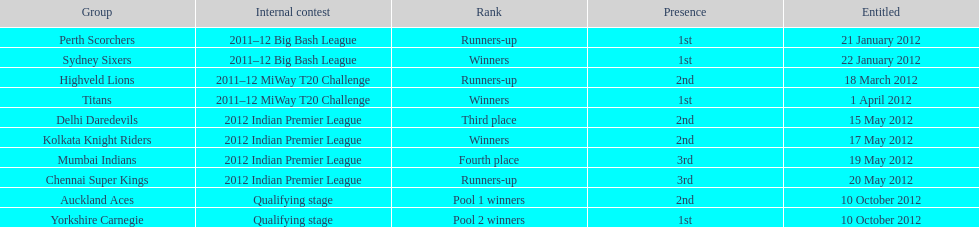Parse the full table. {'header': ['Group', 'Internal contest', 'Rank', 'Presence', 'Entitled'], 'rows': [['Perth Scorchers', '2011–12 Big Bash League', 'Runners-up', '1st', '21 January 2012'], ['Sydney Sixers', '2011–12 Big Bash League', 'Winners', '1st', '22 January 2012'], ['Highveld Lions', '2011–12 MiWay T20 Challenge', 'Runners-up', '2nd', '18 March 2012'], ['Titans', '2011–12 MiWay T20 Challenge', 'Winners', '1st', '1 April 2012'], ['Delhi Daredevils', '2012 Indian Premier League', 'Third place', '2nd', '15 May 2012'], ['Kolkata Knight Riders', '2012 Indian Premier League', 'Winners', '2nd', '17 May 2012'], ['Mumbai Indians', '2012 Indian Premier League', 'Fourth place', '3rd', '19 May 2012'], ['Chennai Super Kings', '2012 Indian Premier League', 'Runners-up', '3rd', '20 May 2012'], ['Auckland Aces', 'Qualifying stage', 'Pool 1 winners', '2nd', '10 October 2012'], ['Yorkshire Carnegie', 'Qualifying stage', 'Pool 2 winners', '1st', '10 October 2012']]} The auckland aces and yorkshire carnegie qualified on what date? 10 October 2012. 